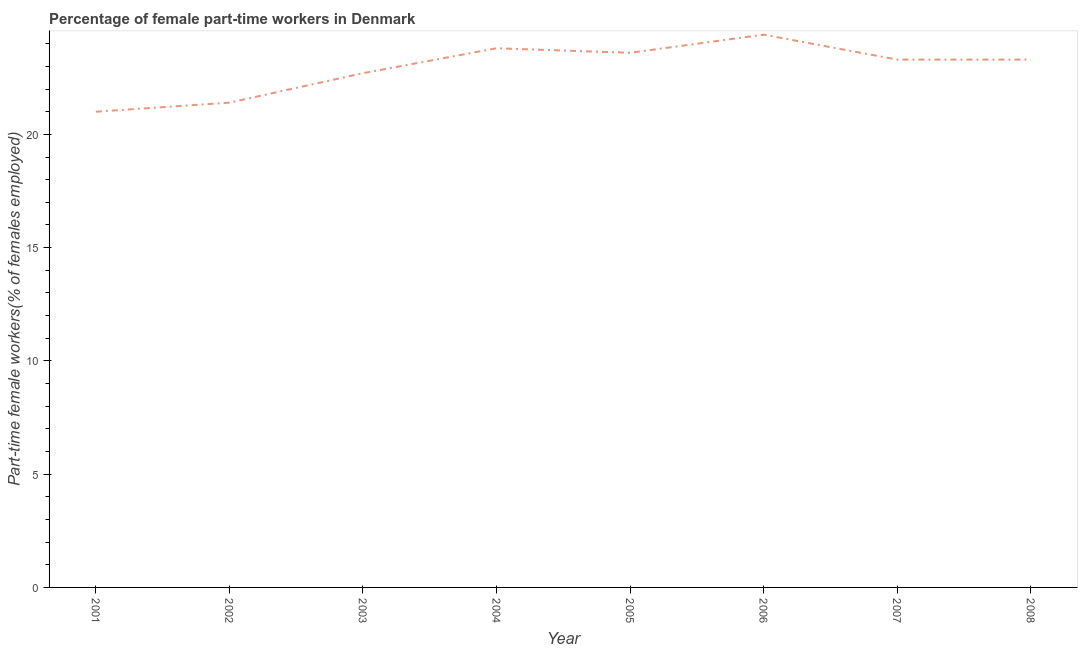What is the percentage of part-time female workers in 2007?
Give a very brief answer. 23.3. Across all years, what is the maximum percentage of part-time female workers?
Give a very brief answer. 24.4. In which year was the percentage of part-time female workers minimum?
Keep it short and to the point. 2001. What is the sum of the percentage of part-time female workers?
Your answer should be very brief. 183.5. What is the difference between the percentage of part-time female workers in 2007 and 2008?
Offer a very short reply. 0. What is the average percentage of part-time female workers per year?
Your response must be concise. 22.94. What is the median percentage of part-time female workers?
Offer a terse response. 23.3. In how many years, is the percentage of part-time female workers greater than 11 %?
Give a very brief answer. 8. Do a majority of the years between 2003 and 2002 (inclusive) have percentage of part-time female workers greater than 12 %?
Provide a succinct answer. No. What is the ratio of the percentage of part-time female workers in 2003 to that in 2004?
Make the answer very short. 0.95. Is the percentage of part-time female workers in 2006 less than that in 2007?
Make the answer very short. No. Is the difference between the percentage of part-time female workers in 2003 and 2006 greater than the difference between any two years?
Provide a short and direct response. No. What is the difference between the highest and the second highest percentage of part-time female workers?
Offer a terse response. 0.6. What is the difference between the highest and the lowest percentage of part-time female workers?
Your answer should be compact. 3.4. Does the percentage of part-time female workers monotonically increase over the years?
Your answer should be compact. No. What is the title of the graph?
Provide a succinct answer. Percentage of female part-time workers in Denmark. What is the label or title of the X-axis?
Keep it short and to the point. Year. What is the label or title of the Y-axis?
Keep it short and to the point. Part-time female workers(% of females employed). What is the Part-time female workers(% of females employed) of 2001?
Your answer should be very brief. 21. What is the Part-time female workers(% of females employed) of 2002?
Ensure brevity in your answer.  21.4. What is the Part-time female workers(% of females employed) of 2003?
Your answer should be compact. 22.7. What is the Part-time female workers(% of females employed) of 2004?
Give a very brief answer. 23.8. What is the Part-time female workers(% of females employed) of 2005?
Make the answer very short. 23.6. What is the Part-time female workers(% of females employed) of 2006?
Make the answer very short. 24.4. What is the Part-time female workers(% of females employed) of 2007?
Your response must be concise. 23.3. What is the Part-time female workers(% of females employed) in 2008?
Your answer should be very brief. 23.3. What is the difference between the Part-time female workers(% of females employed) in 2001 and 2004?
Your answer should be compact. -2.8. What is the difference between the Part-time female workers(% of females employed) in 2001 and 2005?
Make the answer very short. -2.6. What is the difference between the Part-time female workers(% of females employed) in 2001 and 2007?
Your answer should be compact. -2.3. What is the difference between the Part-time female workers(% of females employed) in 2001 and 2008?
Offer a very short reply. -2.3. What is the difference between the Part-time female workers(% of females employed) in 2002 and 2003?
Keep it short and to the point. -1.3. What is the difference between the Part-time female workers(% of females employed) in 2003 and 2005?
Your answer should be very brief. -0.9. What is the difference between the Part-time female workers(% of females employed) in 2003 and 2007?
Provide a succinct answer. -0.6. What is the difference between the Part-time female workers(% of females employed) in 2003 and 2008?
Give a very brief answer. -0.6. What is the difference between the Part-time female workers(% of females employed) in 2004 and 2007?
Ensure brevity in your answer.  0.5. What is the difference between the Part-time female workers(% of females employed) in 2004 and 2008?
Give a very brief answer. 0.5. What is the difference between the Part-time female workers(% of females employed) in 2005 and 2006?
Provide a short and direct response. -0.8. What is the difference between the Part-time female workers(% of females employed) in 2005 and 2008?
Give a very brief answer. 0.3. What is the difference between the Part-time female workers(% of females employed) in 2006 and 2007?
Your answer should be compact. 1.1. What is the ratio of the Part-time female workers(% of females employed) in 2001 to that in 2002?
Offer a terse response. 0.98. What is the ratio of the Part-time female workers(% of females employed) in 2001 to that in 2003?
Keep it short and to the point. 0.93. What is the ratio of the Part-time female workers(% of females employed) in 2001 to that in 2004?
Offer a very short reply. 0.88. What is the ratio of the Part-time female workers(% of females employed) in 2001 to that in 2005?
Ensure brevity in your answer.  0.89. What is the ratio of the Part-time female workers(% of females employed) in 2001 to that in 2006?
Keep it short and to the point. 0.86. What is the ratio of the Part-time female workers(% of females employed) in 2001 to that in 2007?
Offer a terse response. 0.9. What is the ratio of the Part-time female workers(% of females employed) in 2001 to that in 2008?
Your answer should be very brief. 0.9. What is the ratio of the Part-time female workers(% of females employed) in 2002 to that in 2003?
Your answer should be very brief. 0.94. What is the ratio of the Part-time female workers(% of females employed) in 2002 to that in 2004?
Make the answer very short. 0.9. What is the ratio of the Part-time female workers(% of females employed) in 2002 to that in 2005?
Keep it short and to the point. 0.91. What is the ratio of the Part-time female workers(% of females employed) in 2002 to that in 2006?
Make the answer very short. 0.88. What is the ratio of the Part-time female workers(% of females employed) in 2002 to that in 2007?
Ensure brevity in your answer.  0.92. What is the ratio of the Part-time female workers(% of females employed) in 2002 to that in 2008?
Keep it short and to the point. 0.92. What is the ratio of the Part-time female workers(% of females employed) in 2003 to that in 2004?
Provide a short and direct response. 0.95. What is the ratio of the Part-time female workers(% of females employed) in 2003 to that in 2005?
Provide a succinct answer. 0.96. What is the ratio of the Part-time female workers(% of females employed) in 2003 to that in 2006?
Provide a short and direct response. 0.93. What is the ratio of the Part-time female workers(% of females employed) in 2003 to that in 2008?
Your response must be concise. 0.97. What is the ratio of the Part-time female workers(% of females employed) in 2004 to that in 2006?
Your response must be concise. 0.97. What is the ratio of the Part-time female workers(% of females employed) in 2005 to that in 2006?
Your answer should be compact. 0.97. What is the ratio of the Part-time female workers(% of females employed) in 2005 to that in 2008?
Make the answer very short. 1.01. What is the ratio of the Part-time female workers(% of females employed) in 2006 to that in 2007?
Give a very brief answer. 1.05. What is the ratio of the Part-time female workers(% of females employed) in 2006 to that in 2008?
Your answer should be compact. 1.05. What is the ratio of the Part-time female workers(% of females employed) in 2007 to that in 2008?
Your answer should be very brief. 1. 